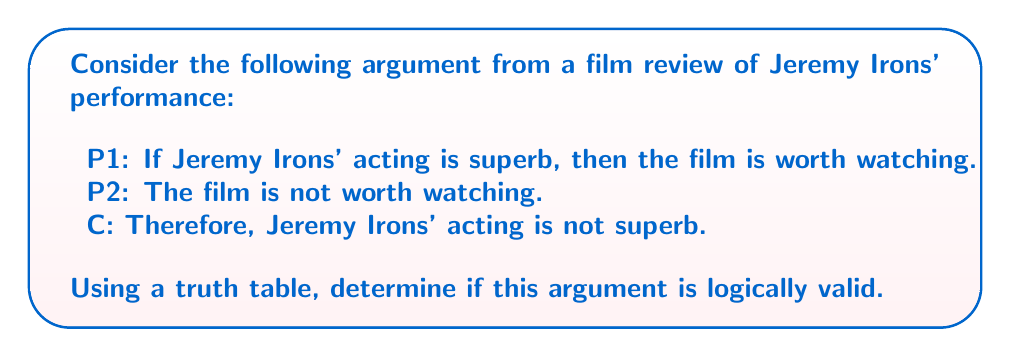Teach me how to tackle this problem. To determine the logical validity of this argument, we need to construct a truth table and examine if the conclusion necessarily follows from the premises. Let's define our propositions:

$p$: Jeremy Irons' acting is superb
$q$: The film is worth watching

The argument can be symbolized as:
P1: $p \rightarrow q$
P2: $\neg q$
C: $\therefore \neg p$

Now, let's construct the truth table:

$$
\begin{array}{|c|c|c|c|c|c|}
\hline
p & q & p \rightarrow q & \neg q & \neg p & \text{Valid?} \\
\hline
T & T & T & F & F & \text{Yes} \\
T & F & F & T & F & \text{Yes} \\
F & T & T & F & T & \text{Yes} \\
F & F & T & T & T & \text{Yes} \\
\hline
\end{array}
$$

To determine validity, we need to check if there's any row where both premises are true (P1: $p \rightarrow q$ and P2: $\neg q$) but the conclusion ($\neg p$) is false.

The only row where both premises are true is the second row:
$p$ is true, $q$ is false, so $p \rightarrow q$ is false and $\neg q$ is true.

In this case, the conclusion $\neg p$ is also false, which means the argument is valid. The conclusion necessarily follows from the premises.

This form of argument is known as Modus Tollens (denying the consequent), which is a valid form of logical reasoning.
Answer: The argument is logically valid. 